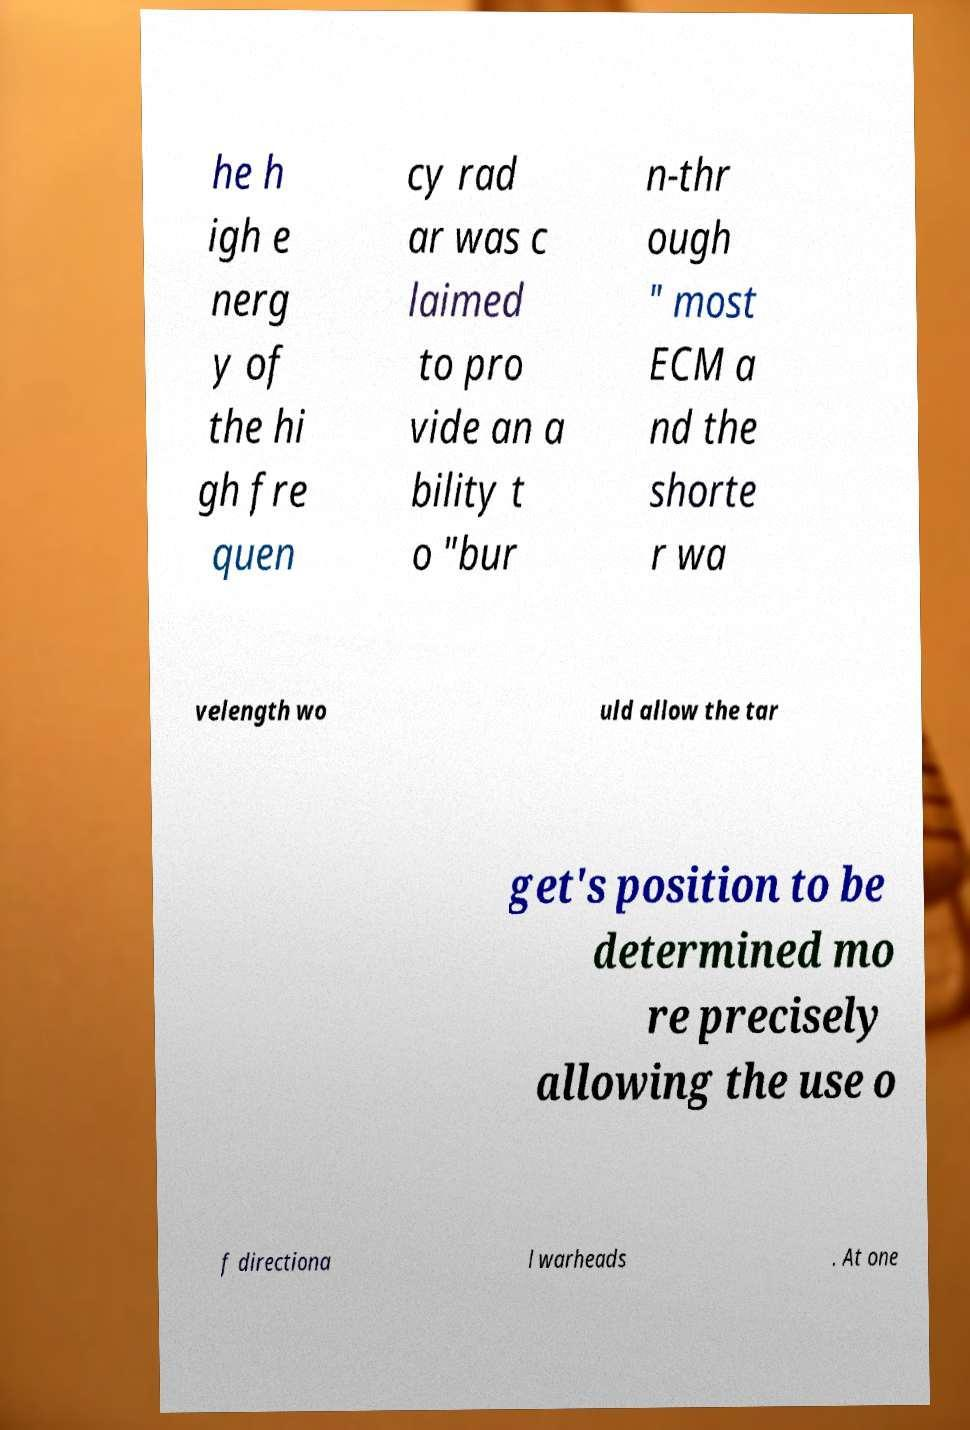Could you extract and type out the text from this image? he h igh e nerg y of the hi gh fre quen cy rad ar was c laimed to pro vide an a bility t o "bur n-thr ough " most ECM a nd the shorte r wa velength wo uld allow the tar get's position to be determined mo re precisely allowing the use o f directiona l warheads . At one 